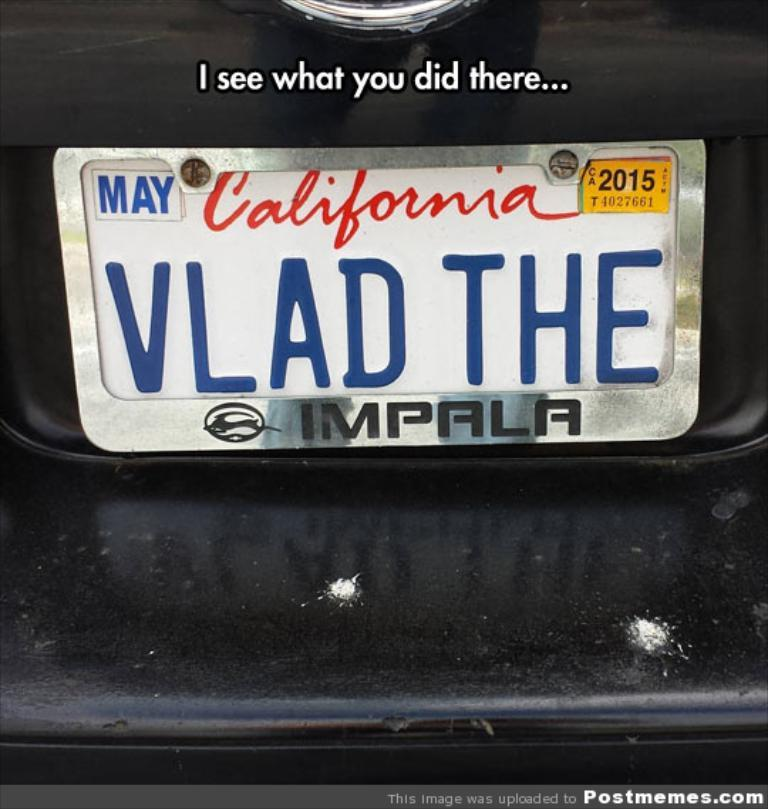<image>
Render a clear and concise summary of the photo. White California license plate which says VLAD THE on the back. 